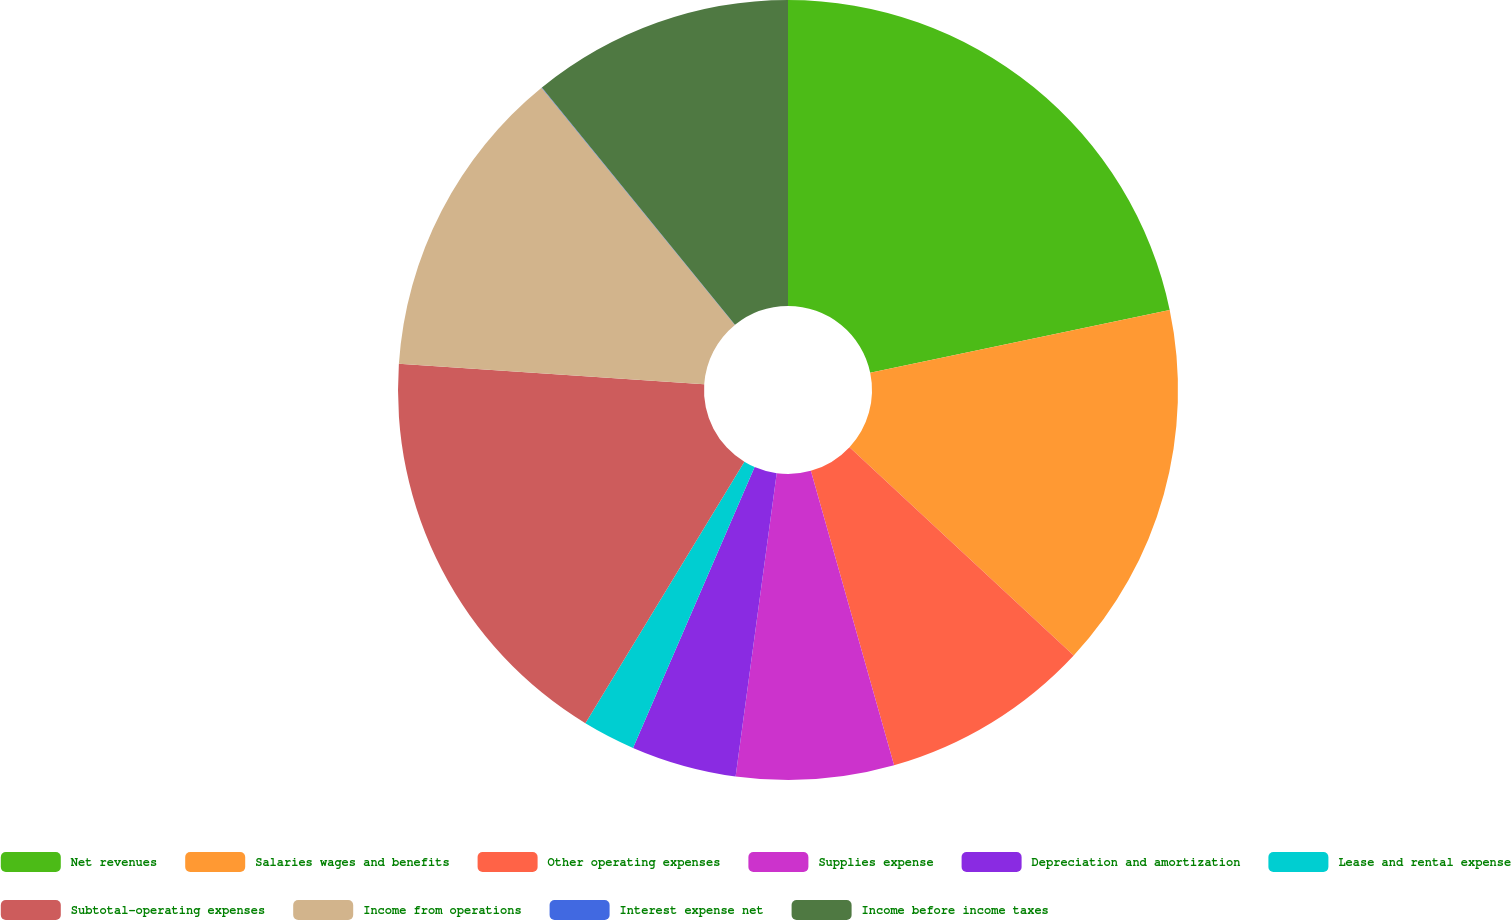Convert chart. <chart><loc_0><loc_0><loc_500><loc_500><pie_chart><fcel>Net revenues<fcel>Salaries wages and benefits<fcel>Other operating expenses<fcel>Supplies expense<fcel>Depreciation and amortization<fcel>Lease and rental expense<fcel>Subtotal-operating expenses<fcel>Income from operations<fcel>Interest expense net<fcel>Income before income taxes<nl><fcel>21.71%<fcel>15.21%<fcel>8.7%<fcel>6.53%<fcel>4.36%<fcel>2.19%<fcel>17.38%<fcel>13.04%<fcel>0.02%<fcel>10.87%<nl></chart> 